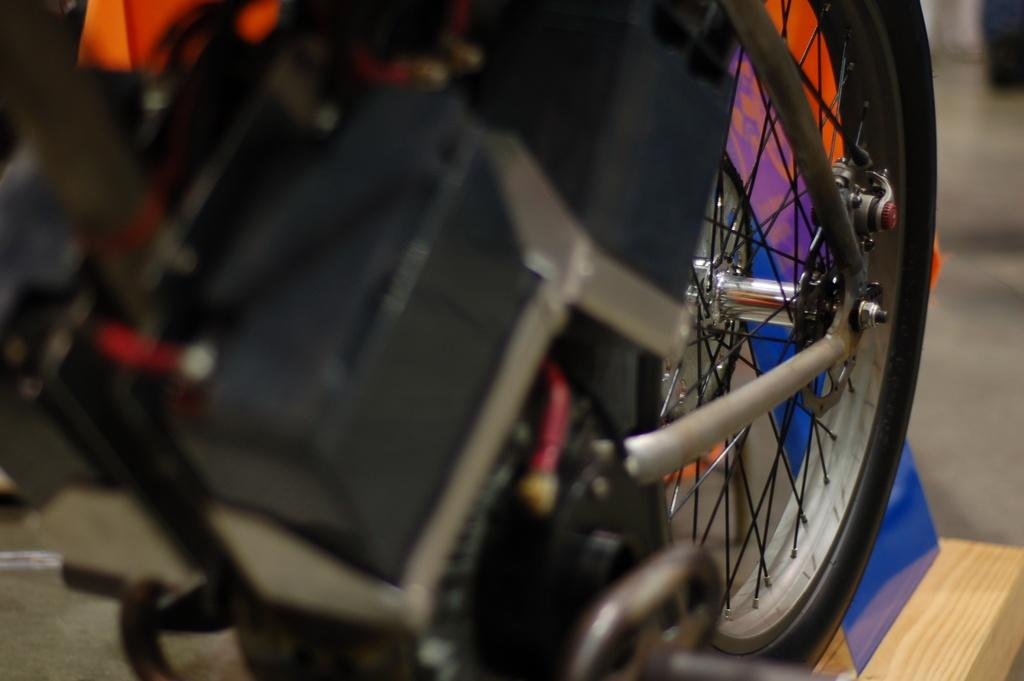What part of a vehicle can be seen in the image? There is a wheel of a vehicle in the image. What type of material is visible in the image? There is wood visible in the image. What is the color of the object in the image? There is a colored object in the image. What is the surface on which the objects are placed in the image? The ground is visible in the image. What type of camp can be seen in the image? There is no camp present in the image; it features a wheel of a vehicle, wood, a colored object, and the ground. 